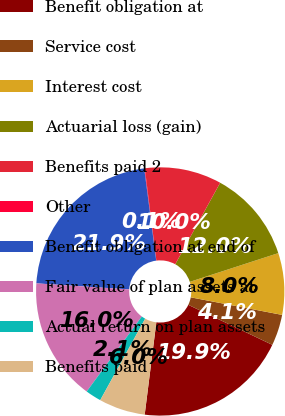<chart> <loc_0><loc_0><loc_500><loc_500><pie_chart><fcel>Benefit obligation at<fcel>Service cost<fcel>Interest cost<fcel>Actuarial loss (gain)<fcel>Benefits paid 2<fcel>Other<fcel>Benefit obligation at end of<fcel>Fair value of plan assets at<fcel>Actual return on plan assets<fcel>Benefits paid<nl><fcel>19.92%<fcel>4.05%<fcel>8.02%<fcel>11.98%<fcel>10.0%<fcel>0.08%<fcel>21.9%<fcel>15.95%<fcel>2.06%<fcel>6.03%<nl></chart> 